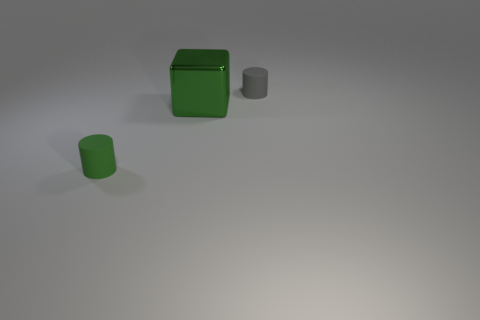Add 1 tiny gray things. How many objects exist? 4 Subtract all cubes. How many objects are left? 2 Add 2 tiny green matte cylinders. How many tiny green matte cylinders exist? 3 Subtract 0 yellow balls. How many objects are left? 3 Subtract all tiny green spheres. Subtract all big cubes. How many objects are left? 2 Add 3 big green cubes. How many big green cubes are left? 4 